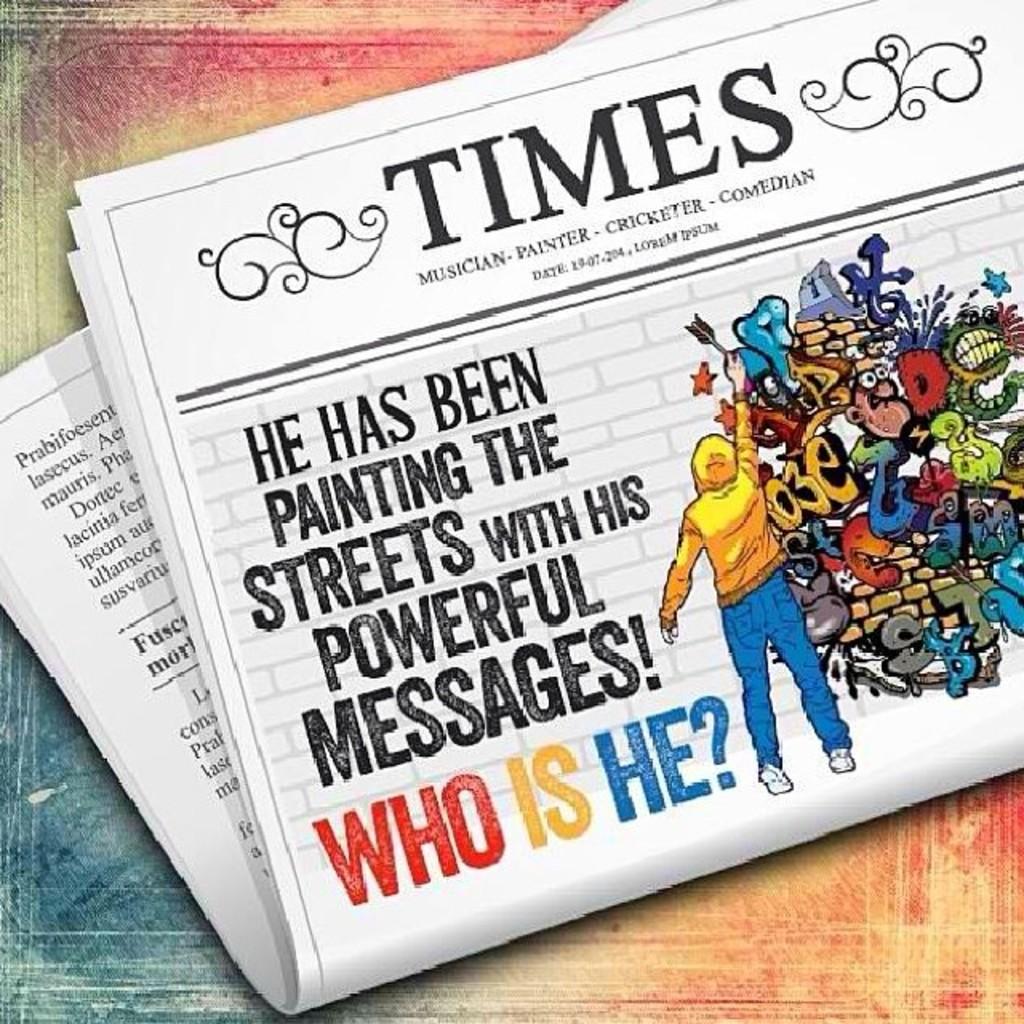What is the title of this apparently fictitious paper?
Provide a succinct answer. Times. What is he painting the streets with?
Give a very brief answer. Powerful messages. 